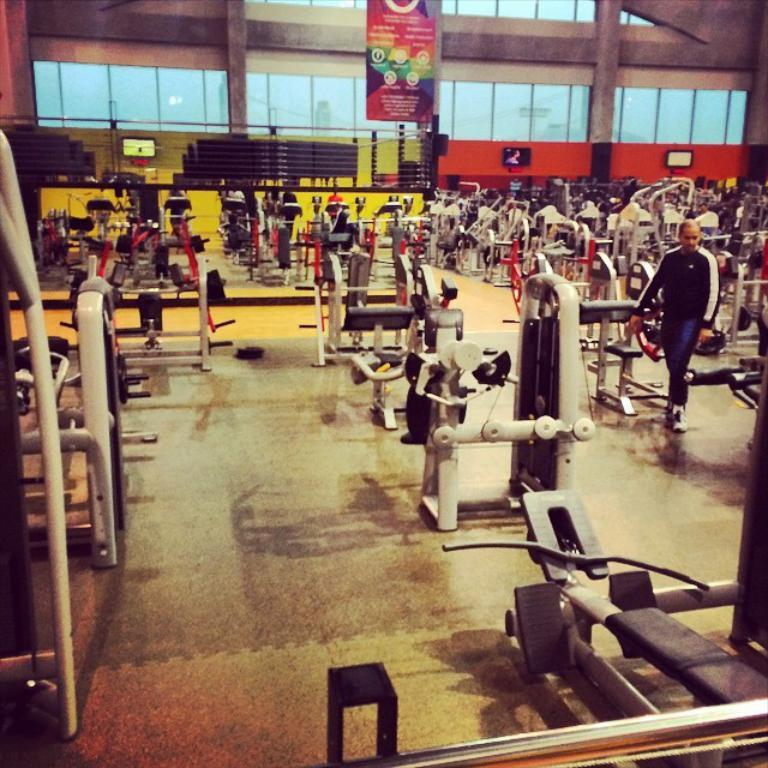What type of equipment can be seen in the image? There is gym equipment in the image. What is the person on the floor doing in the image? The person on the floor is likely exercising or using the gym equipment. What can be seen in the background of the image? There is a banner, televisions, a wall, glass, and other objects visible in the background of the image. What type of pencil is being used to draw on the glass in the image? There is no pencil or drawing on the glass present in the image. How does the person on the floor plan to transport the gym equipment out of the room? The image does not show any indication of the person planning to transport the gym equipment, nor does it show any means of transport. 